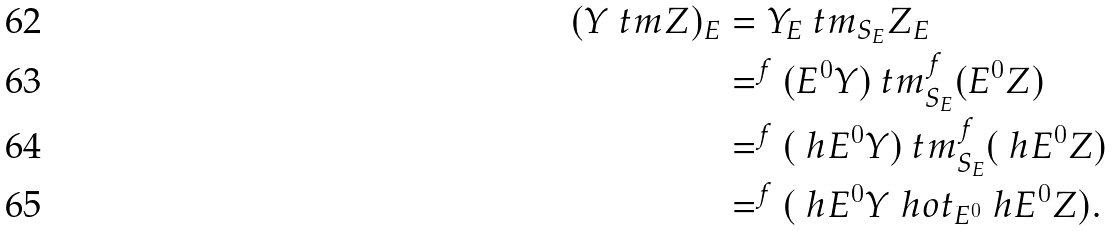<formula> <loc_0><loc_0><loc_500><loc_500>( Y \ t m Z ) _ { E } & = Y _ { E } \ t m _ { S _ { E } } Z _ { E } \\ & = ^ { f } ( E ^ { 0 } Y ) \ t m _ { S _ { E } } ^ { f } ( E ^ { 0 } Z ) \\ & = ^ { f } ( \ h E ^ { 0 } Y ) \ t m _ { S _ { E } } ^ { f } ( \ h E ^ { 0 } Z ) \\ & = ^ { f } ( \ h E ^ { 0 } Y \ h o t _ { E ^ { 0 } } \ h E ^ { 0 } Z ) .</formula> 